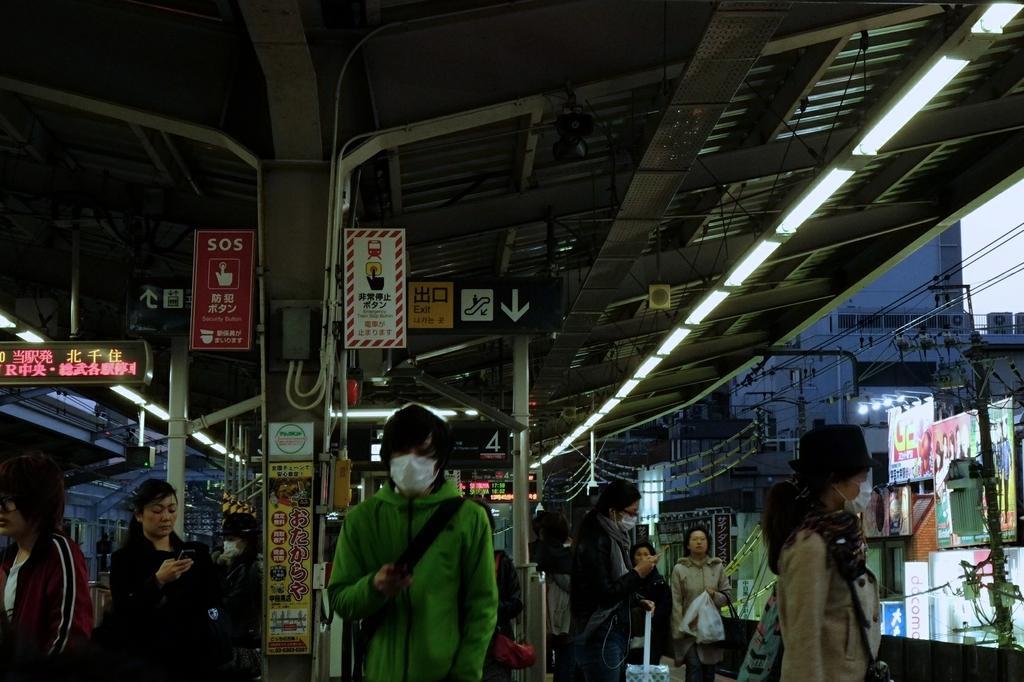In one or two sentences, can you explain what this image depicts? This image is taken during the evening time. In this image we can see the people. At the top we can see the roof for shelter. We can also see the lights, hoarding, electrical poles with wires and also buildings. We can also see the banners, sign board and also the display screen. We can also see the sky. 